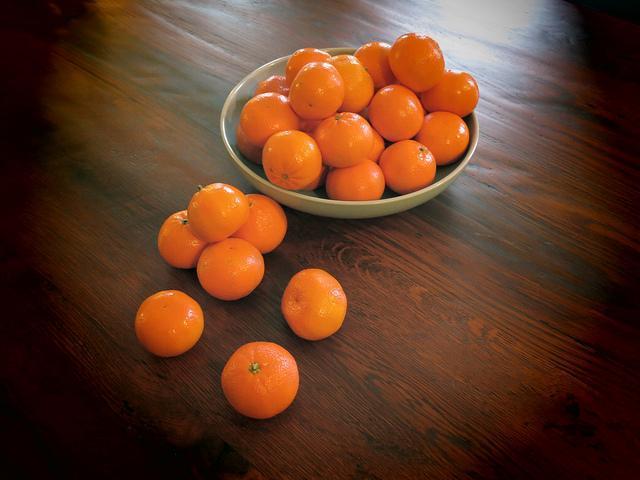How many oranges are there?
Give a very brief answer. 7. How many women are under the umbrella?
Give a very brief answer. 0. 